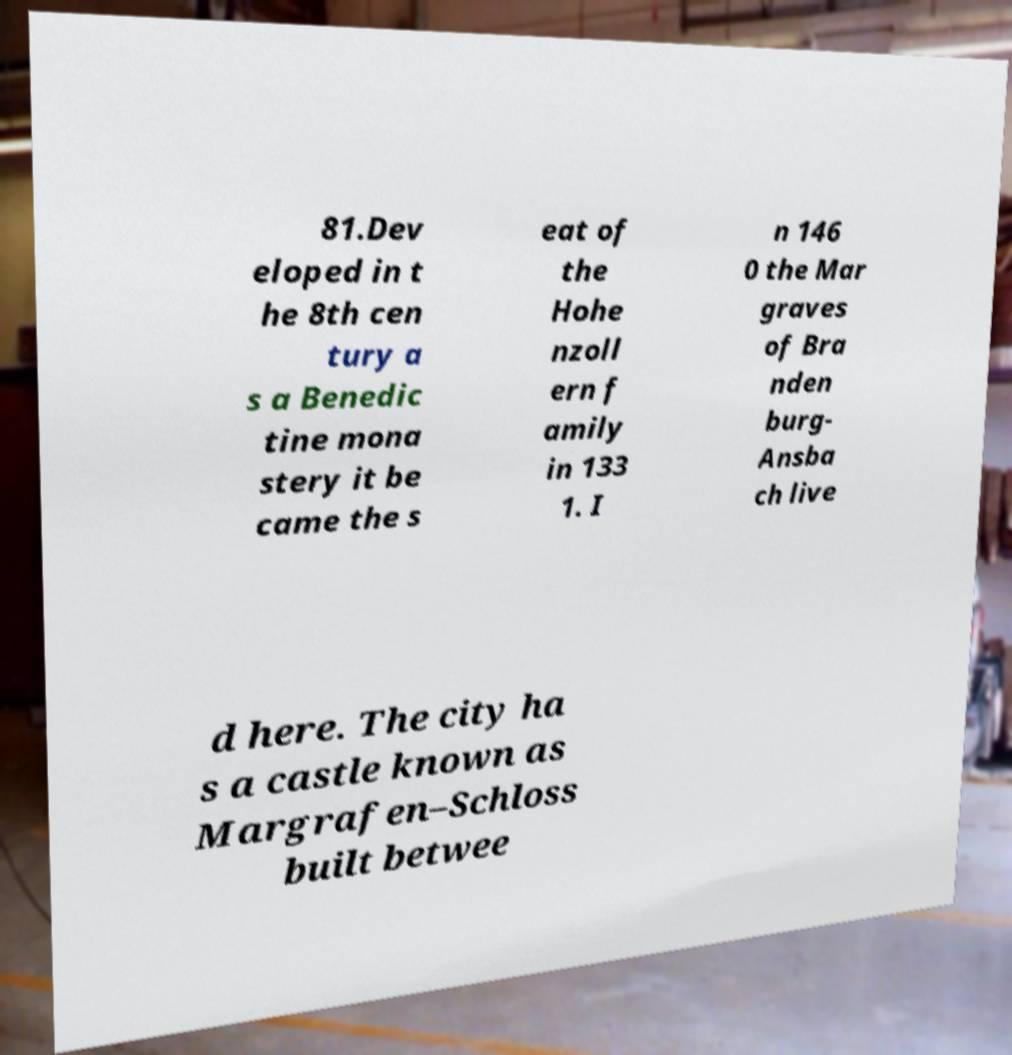Please identify and transcribe the text found in this image. 81.Dev eloped in t he 8th cen tury a s a Benedic tine mona stery it be came the s eat of the Hohe nzoll ern f amily in 133 1. I n 146 0 the Mar graves of Bra nden burg- Ansba ch live d here. The city ha s a castle known as Margrafen–Schloss built betwee 